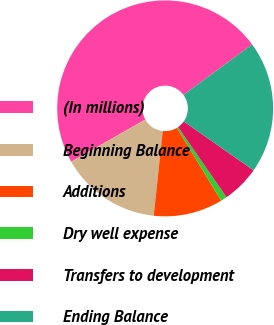<chart> <loc_0><loc_0><loc_500><loc_500><pie_chart><fcel>(In millions)<fcel>Beginning Balance<fcel>Additions<fcel>Dry well expense<fcel>Transfers to development<fcel>Ending Balance<nl><fcel>48.13%<fcel>15.09%<fcel>10.37%<fcel>0.94%<fcel>5.65%<fcel>19.81%<nl></chart> 